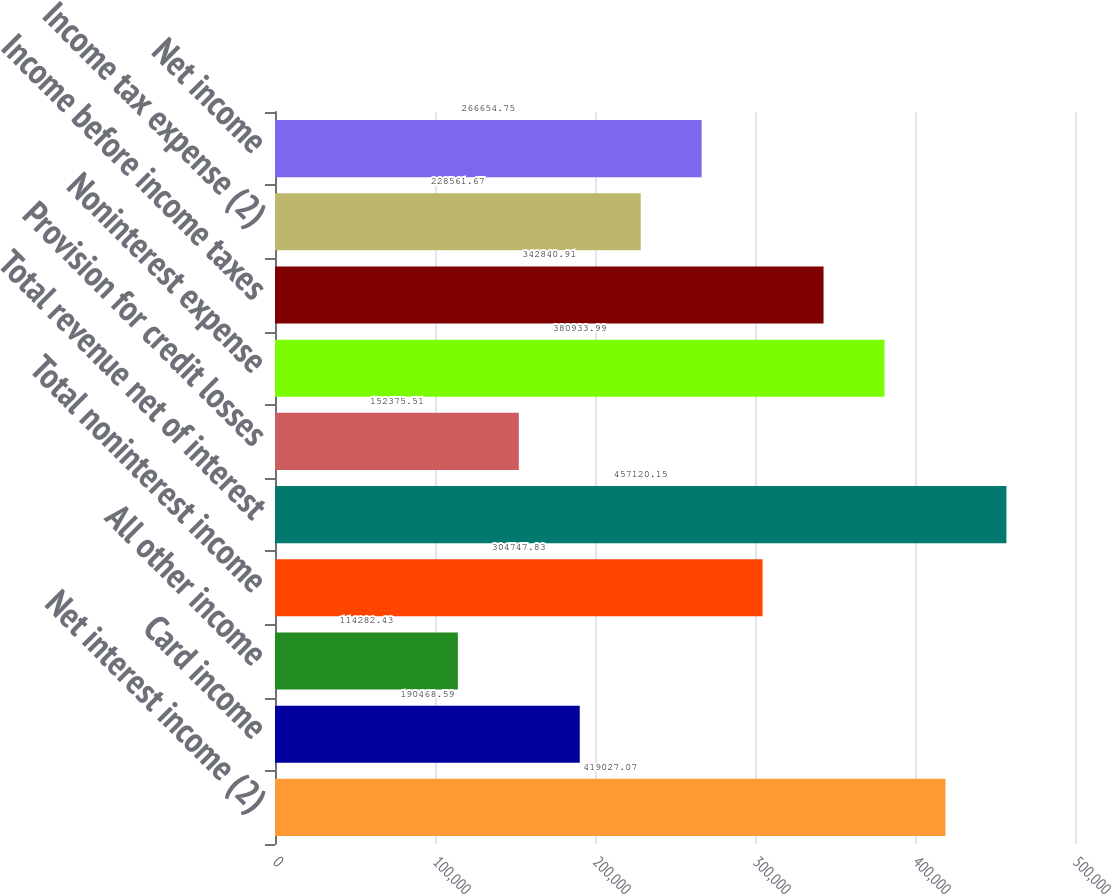Convert chart. <chart><loc_0><loc_0><loc_500><loc_500><bar_chart><fcel>Net interest income (2)<fcel>Card income<fcel>All other income<fcel>Total noninterest income<fcel>Total revenue net of interest<fcel>Provision for credit losses<fcel>Noninterest expense<fcel>Income before income taxes<fcel>Income tax expense (2)<fcel>Net income<nl><fcel>419027<fcel>190469<fcel>114282<fcel>304748<fcel>457120<fcel>152376<fcel>380934<fcel>342841<fcel>228562<fcel>266655<nl></chart> 